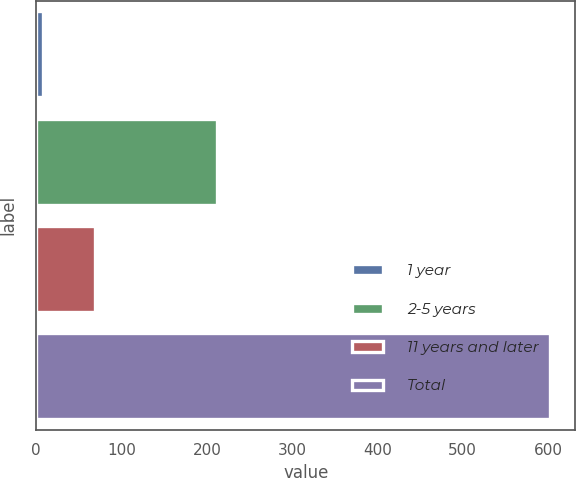Convert chart. <chart><loc_0><loc_0><loc_500><loc_500><bar_chart><fcel>1 year<fcel>2-5 years<fcel>11 years and later<fcel>Total<nl><fcel>8<fcel>212<fcel>69<fcel>602<nl></chart> 